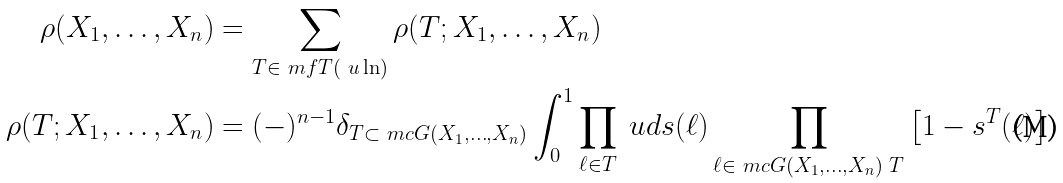Convert formula to latex. <formula><loc_0><loc_0><loc_500><loc_500>\rho ( X _ { 1 } , \dots , X _ { n } ) & = \sum _ { T \in \ m f T ( \ u \ln ) } \rho ( T ; X _ { 1 } , \dots , X _ { n } ) \\ \rho ( T ; X _ { 1 } , \dots , X _ { n } ) & = ( - ) ^ { n - 1 } \delta _ { T \subset \ m c G ( X _ { 1 } , \dots , X _ { n } ) } \int _ { 0 } ^ { 1 } \prod _ { \ell \in T } \ u d s ( \ell ) \prod _ { \ell \in \ m c G ( X _ { 1 } , \dots , X _ { n } ) \ T } \left [ 1 - s ^ { T } ( \ell ) \right ]</formula> 